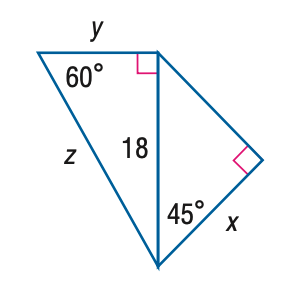Answer the mathemtical geometry problem and directly provide the correct option letter.
Question: Find y.
Choices: A: 9 B: 6 \sqrt { 3 } C: 18 D: 18 \sqrt { 3 } B 